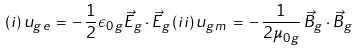Convert formula to latex. <formula><loc_0><loc_0><loc_500><loc_500>( i ) \, u _ { g \, e } \, = \, - \, { \frac { 1 } { 2 } } \epsilon _ { 0 \, g } \vec { E } _ { g } \cdot \vec { E } _ { g } \, ( i i ) \, u _ { g \, m } \, = \, - \, \frac { 1 } { 2 \mu _ { 0 \, g } } \, \vec { B } _ { g } \cdot \vec { B } _ { g }</formula> 